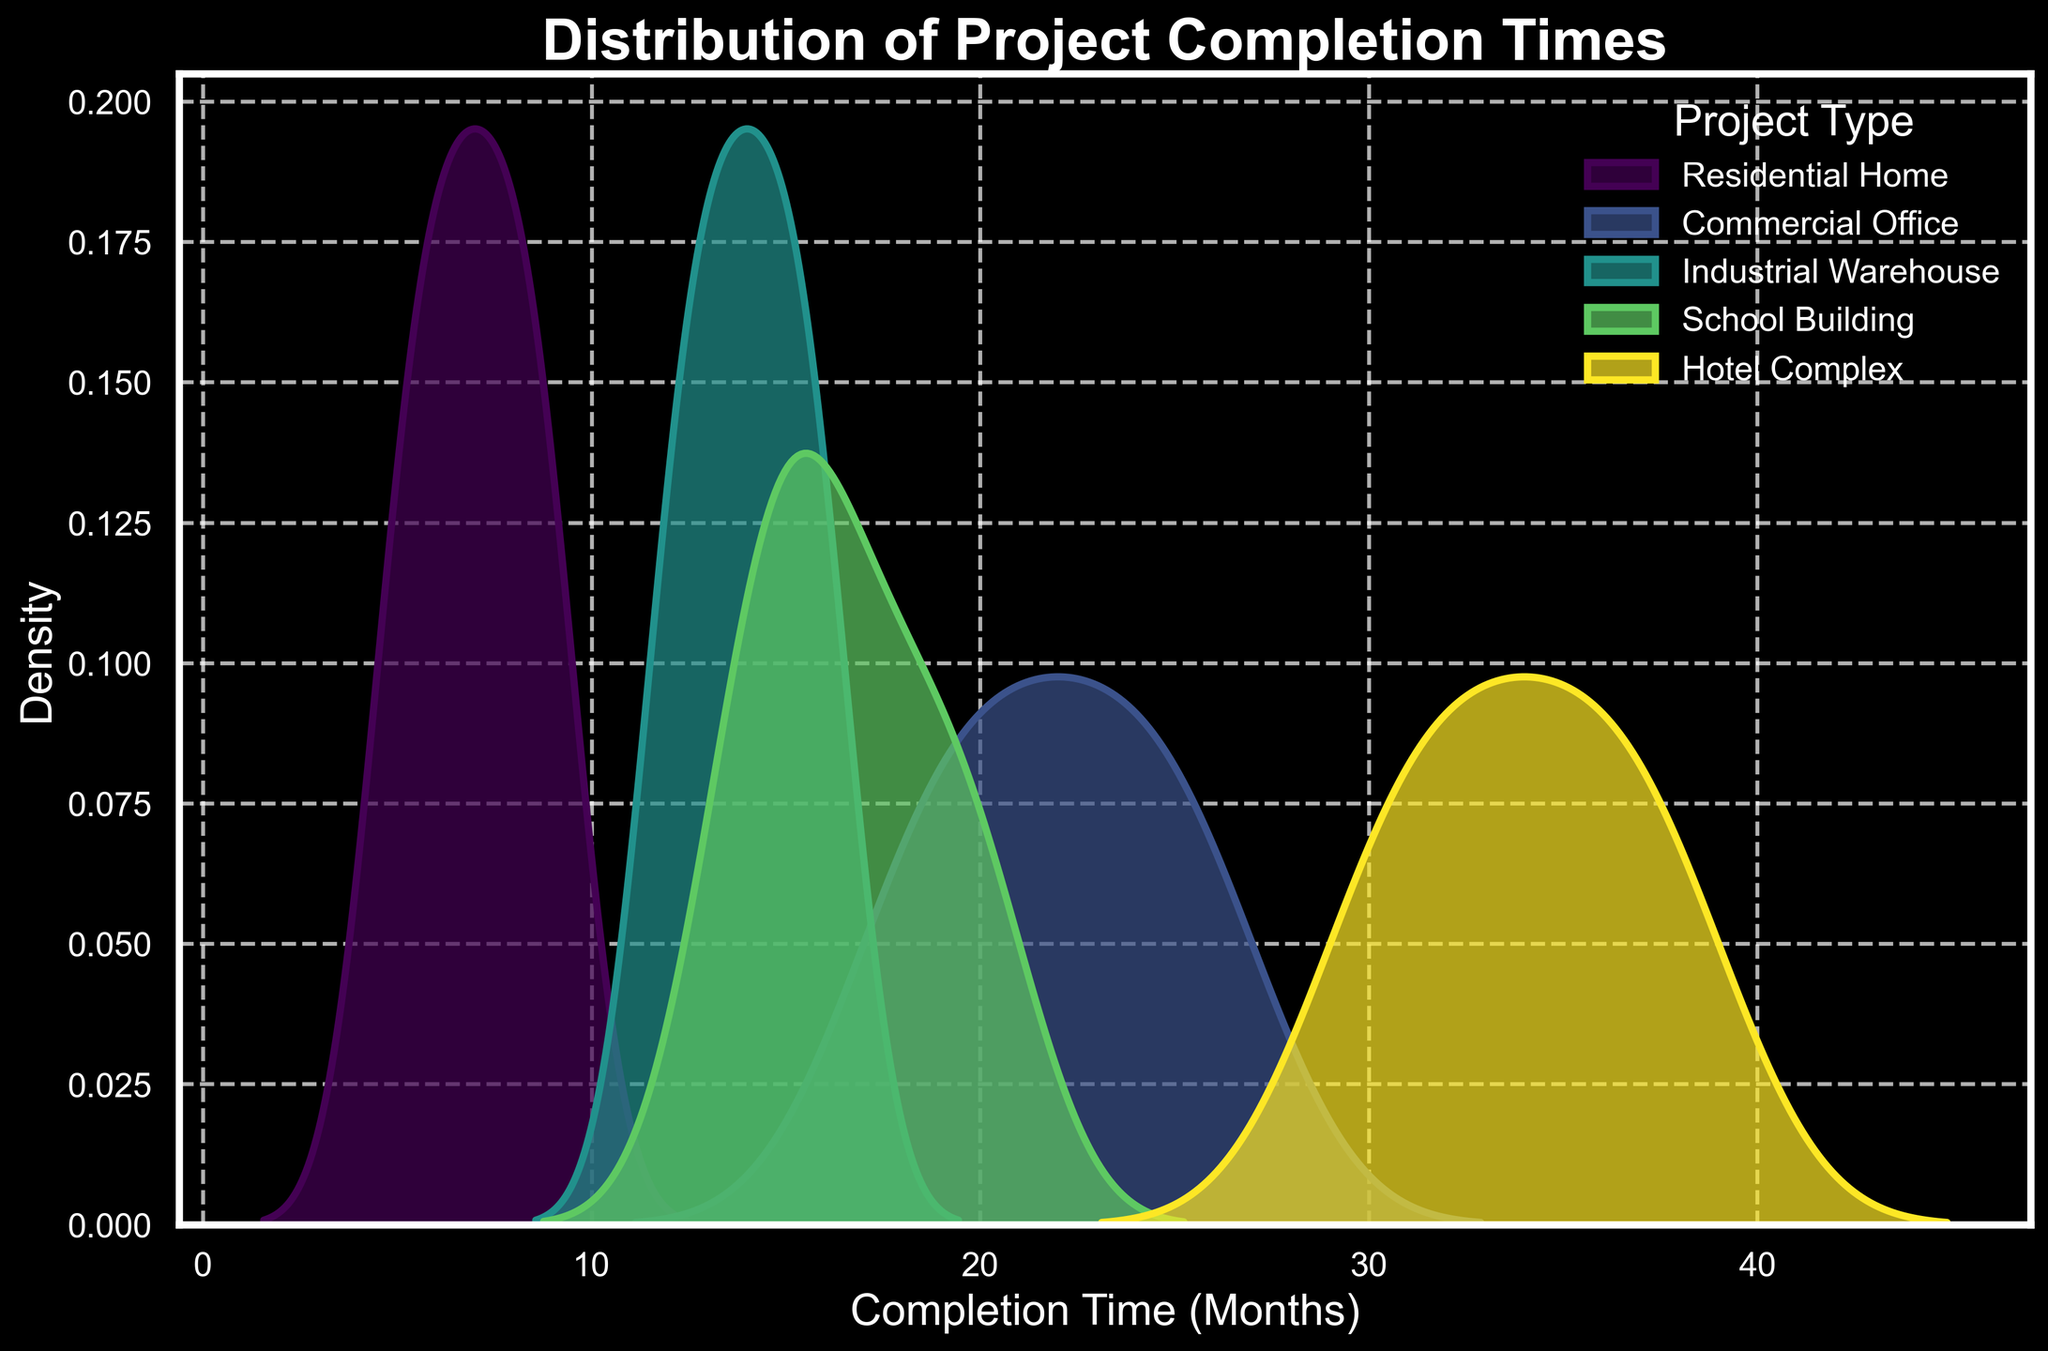What is the title of the figure? The title of the figure is usually displayed prominently at the top. By referring to the top of the plot, we can see what the main subject of the chart is.
Answer: Distribution of Project Completion Times What is the range of completion times for Commercial Office projects? The completion time range can be determined by looking at where the Commercial Office density curve starts and ends on the x-axis.
Answer: 18 to 26 months Which project type has the longest completion time? By looking at the furthest point to the right along the x-axis for each density plot, we can see which project type extends the longest.
Answer: Hotel Complex How many different project types are shown in the figure? The number of project types can be determined by counting the different colored density curves in the legend.
Answer: 5 Which project types have overlapping completion times? We need to observe where the density curves overlap on the x-axis.
Answer: Industrial Warehouse and School Building What is the median completion time for Residential Home projects? The peak of the density curve for Residential Homes typically indicates the median. Find the x-axis value where the Residential Home curve is highest.
Answer: 7 months Does the plot show any project type that completes faster than others? We need to identify the density curve with the lowest x-axis values and see how it compares to others.
Answer: Yes, Residential Home Which project type shows the broadest range in completion times? The breadth of the range can be observed by comparing the x-axis spread of each density curve.
Answer: Hotel Complex How does the density curve of School Building projects compare to that of Industrial Warehouse projects? Comparing their curves involves looking at the overlap, the peaks, and the range on the x-axis.
Answer: Similar ranges but different peaks; School Building extends a bit farther Which project type has a more consistent completion time, indicated by a narrower density curve? A narrower curve indicates less variation in completion times. We need to find the narrowest density curve on the plot.
Answer: Industrial Warehouse 